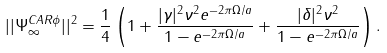<formula> <loc_0><loc_0><loc_500><loc_500>| | \Psi ^ { C A R \phi } _ { \infty } | | ^ { 2 } = \frac { 1 } { 4 } \left ( 1 + \frac { | \gamma | ^ { 2 } \nu ^ { 2 } e ^ { - 2 \pi \Omega / a } } { 1 - e ^ { - 2 \pi \Omega / a } } + \frac { | \delta | ^ { 2 } \nu ^ { 2 } } { 1 - e ^ { - 2 \pi \Omega / a } } \right ) .</formula> 